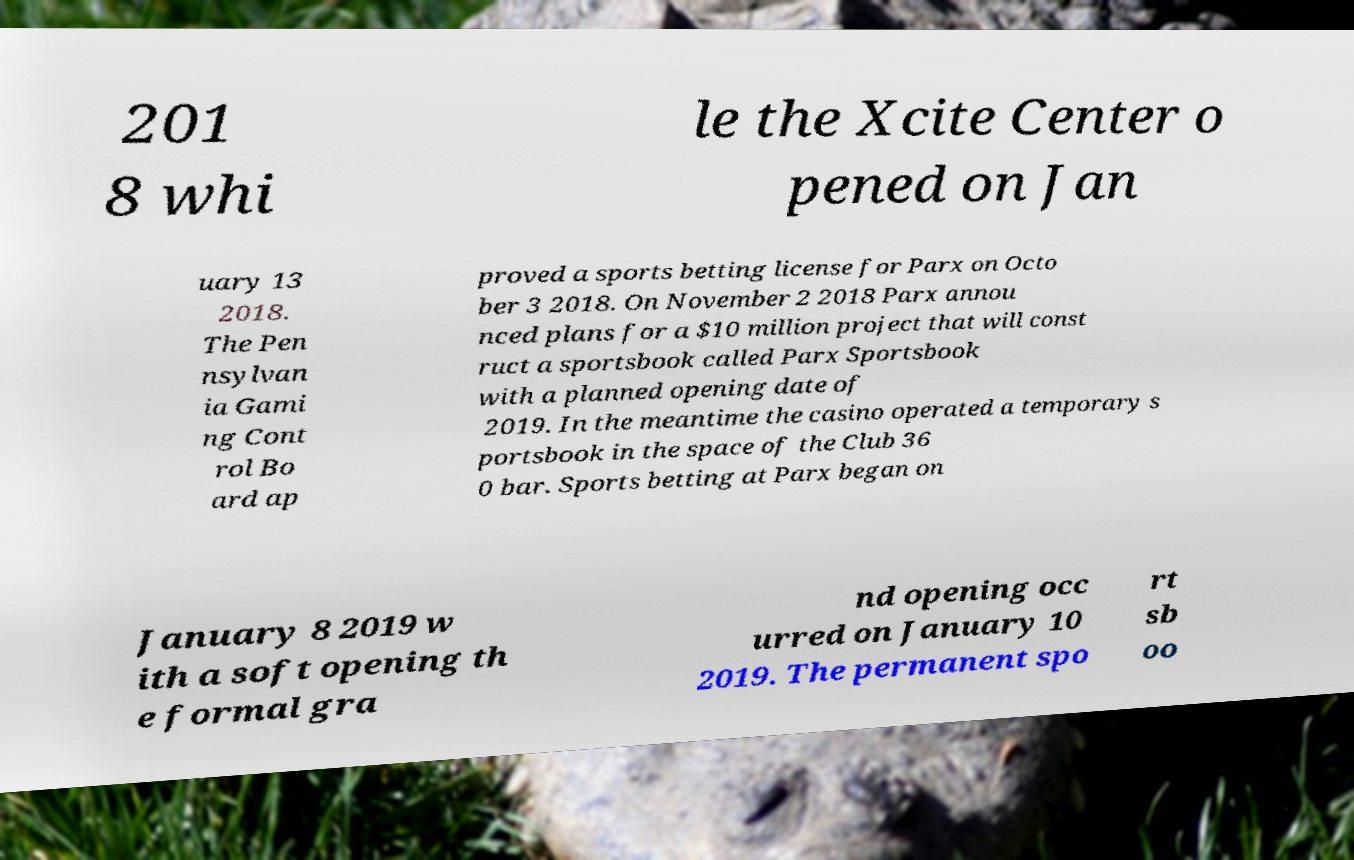Could you extract and type out the text from this image? 201 8 whi le the Xcite Center o pened on Jan uary 13 2018. The Pen nsylvan ia Gami ng Cont rol Bo ard ap proved a sports betting license for Parx on Octo ber 3 2018. On November 2 2018 Parx annou nced plans for a $10 million project that will const ruct a sportsbook called Parx Sportsbook with a planned opening date of 2019. In the meantime the casino operated a temporary s portsbook in the space of the Club 36 0 bar. Sports betting at Parx began on January 8 2019 w ith a soft opening th e formal gra nd opening occ urred on January 10 2019. The permanent spo rt sb oo 